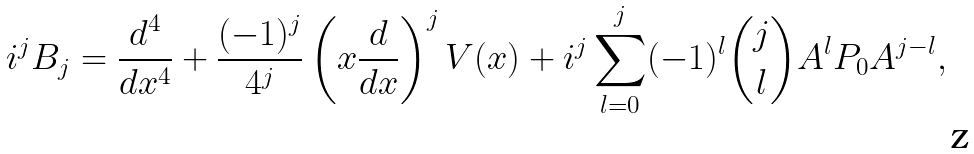<formula> <loc_0><loc_0><loc_500><loc_500>i ^ { j } B _ { j } = \frac { d ^ { 4 } } { d x ^ { 4 } } + \frac { ( - 1 ) ^ { j } } { 4 ^ { j } } \left ( x \frac { d } { d x } \right ) ^ { j } V ( x ) + i ^ { j } \sum _ { l = 0 } ^ { j } ( - 1 ) ^ { l } \binom { j } { l } A ^ { l } P _ { 0 } A ^ { j - l } ,</formula> 